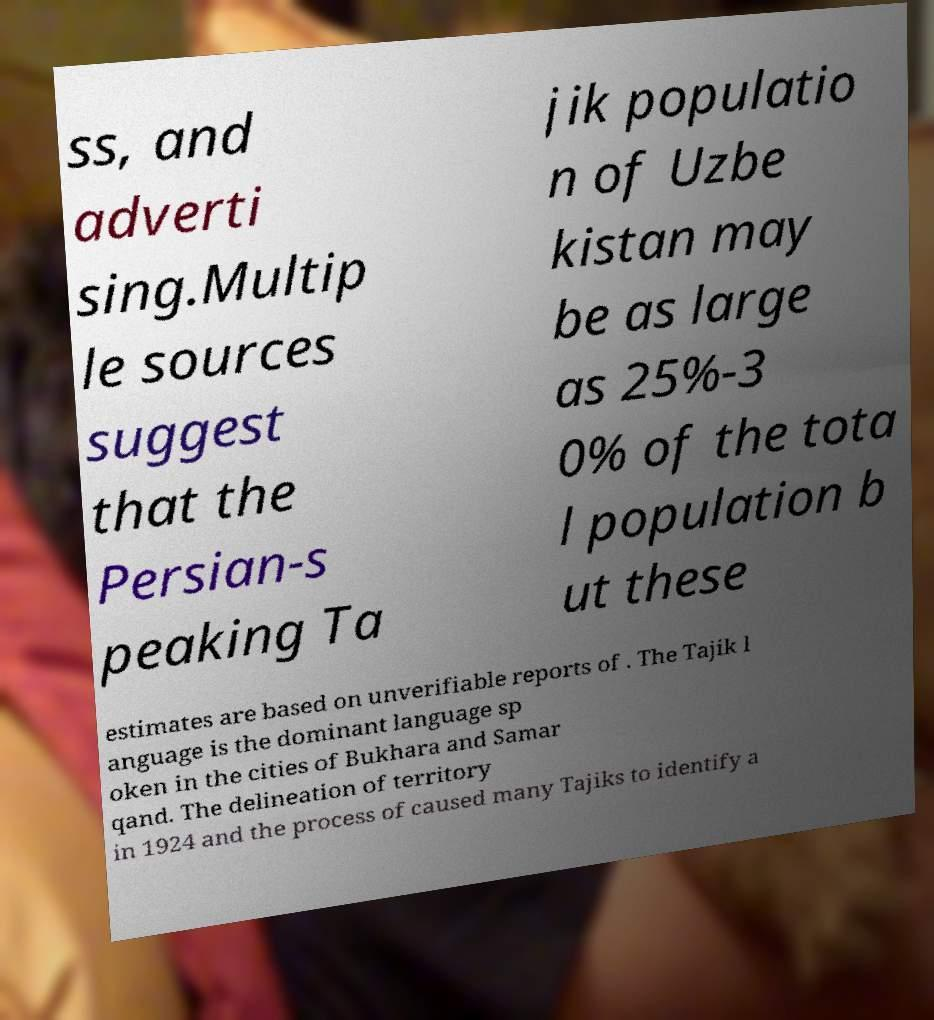Can you accurately transcribe the text from the provided image for me? ss, and adverti sing.Multip le sources suggest that the Persian-s peaking Ta jik populatio n of Uzbe kistan may be as large as 25%-3 0% of the tota l population b ut these estimates are based on unverifiable reports of . The Tajik l anguage is the dominant language sp oken in the cities of Bukhara and Samar qand. The delineation of territory in 1924 and the process of caused many Tajiks to identify a 